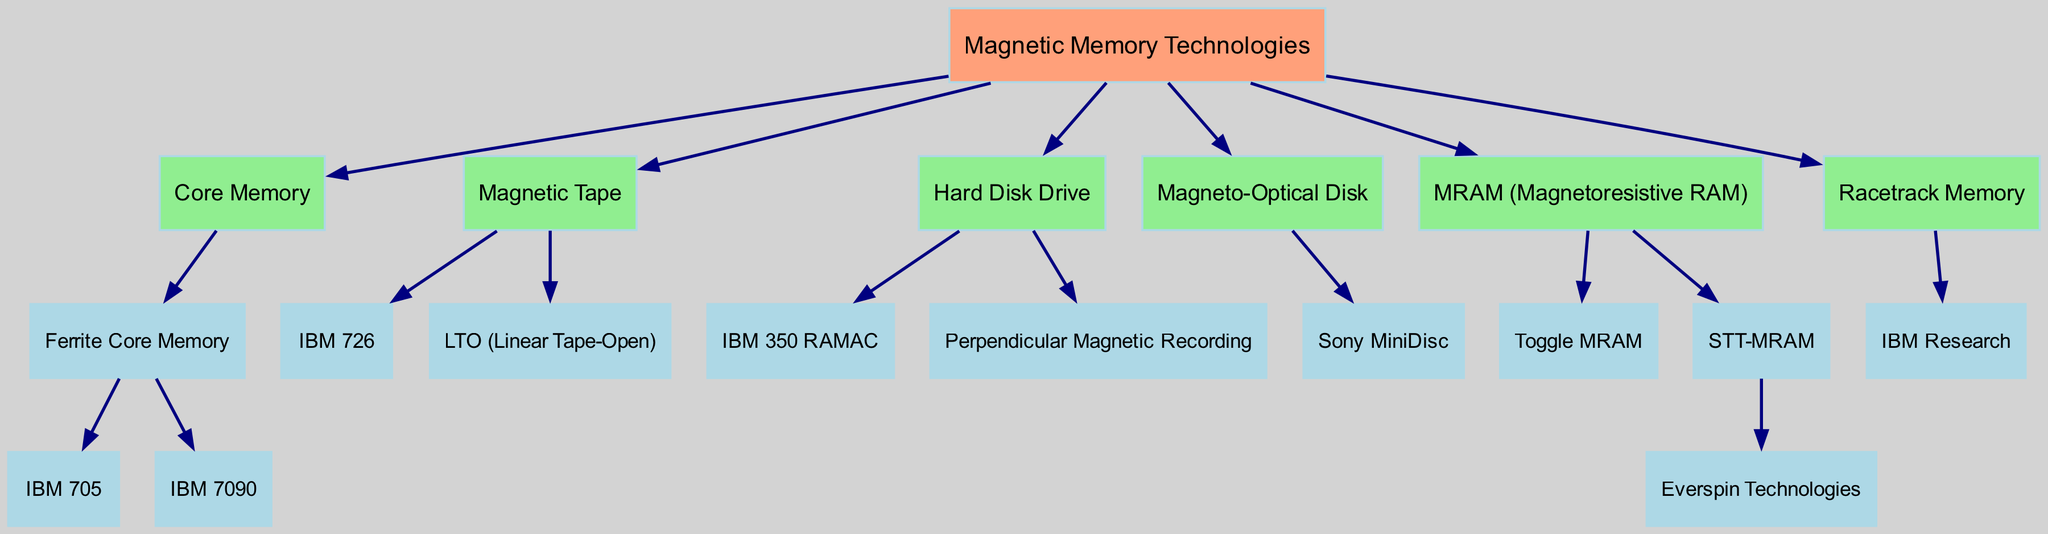What is the first technology listed under Magnetic Memory Technologies? The diagram starts with "Magnetic Memory Technologies" as the root. The first child node under this is "Core Memory".
Answer: Core Memory How many types of memory are classified under Magnetic Memory Technologies? By counting the immediate child nodes under "Magnetic Memory Technologies", we find six distinct types: Core Memory, Magnetic Tape, Hard Disk Drive, Magneto-Optical Disk, MRAM (Magnetoresistive RAM), and Racetrack Memory.
Answer: 6 Which technology has the most specific examples listed in its sub-categories? "MRAM (Magnetoresistive RAM)" contains three sub-categories: Toggle MRAM, STT-MRAM, and Everspin Technologies, the latter being a company example under STT-MRAM. No other category has as many examples.
Answer: MRAM (Magnetoresistive RAM) What two technologies are examples of Hard Disk Drives? The sub-categories under "Hard Disk Drive" include "IBM 350 RAMAC" and "Perpendicular Magnetic Recording". Both of these serve as examples of this technology.
Answer: IBM 350 RAMAC, Perpendicular Magnetic Recording Who is associated with the development of Racetrack Memory? The node "IBM Research" is the only listed example under "Racetrack Memory", indicating that they are involved in this technology.
Answer: IBM Research Which technology listed is an optical storage medium? Looking at the child nodes, "Magneto-Optical Disk" is identified specifically as an optical storage medium, making it the only relevant technology in this context.
Answer: Magneto-Optical Disk How many specific devices or technologies are mentioned under the category of Magnetic Tape? There are two specific examples listed under "Magnetic Tape": "IBM 726" and "LTO (Linear Tape-Open)", making the count two.
Answer: 2 In which technology does the company Everspin Technologies appear? "Everspin Technologies" appears under the "STT-MRAM" category, which is a type of MRAM. It's the only company highlighted in the diagram.
Answer: STT-MRAM What type of recording technology is described in the Hard Disk Drive section? The "Perpendicular Magnetic Recording" is noted under the Hard Disk Drive, indicating a specific type of recording technology associated with disk drives.
Answer: Perpendicular Magnetic Recording 